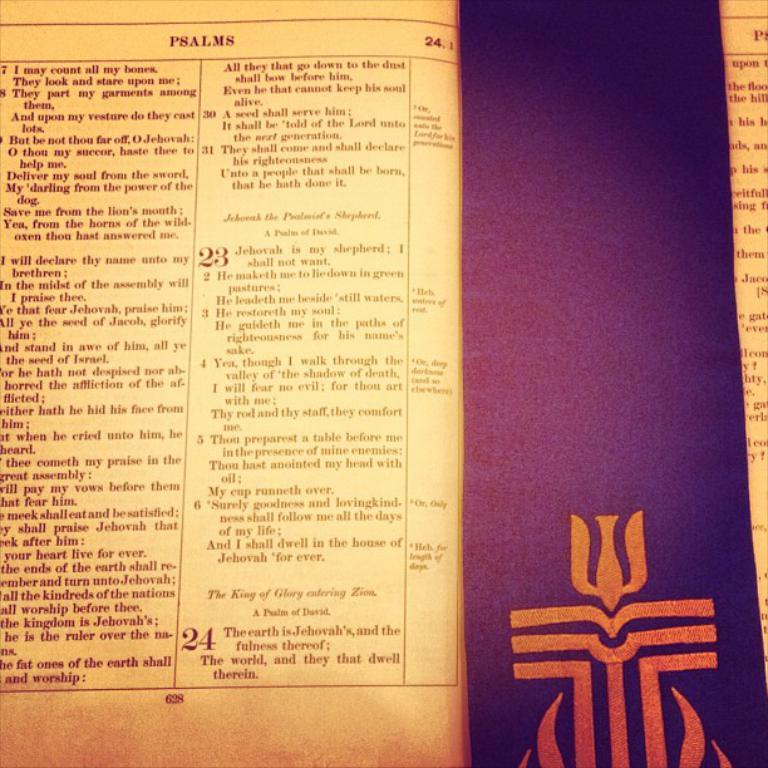<image>
Summarize the visual content of the image. A page from the book of psalms is displayed next to a purple book mark. 